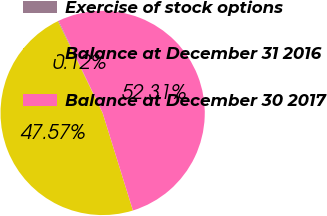<chart> <loc_0><loc_0><loc_500><loc_500><pie_chart><fcel>Exercise of stock options<fcel>Balance at December 31 2016<fcel>Balance at December 30 2017<nl><fcel>0.12%<fcel>47.57%<fcel>52.32%<nl></chart> 